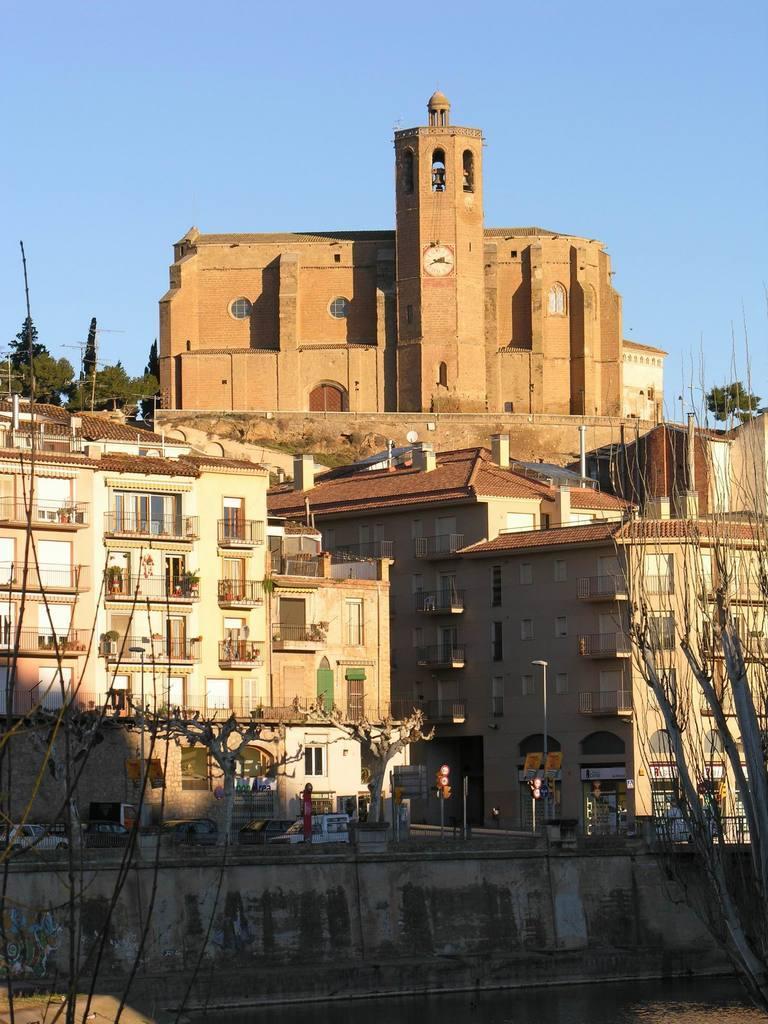In one or two sentences, can you explain what this image depicts? In this image, we can see buildings, trees, poles, vehicles and some boards and there is a bridge. At the bottom, there is water and at the top, there is sky. 